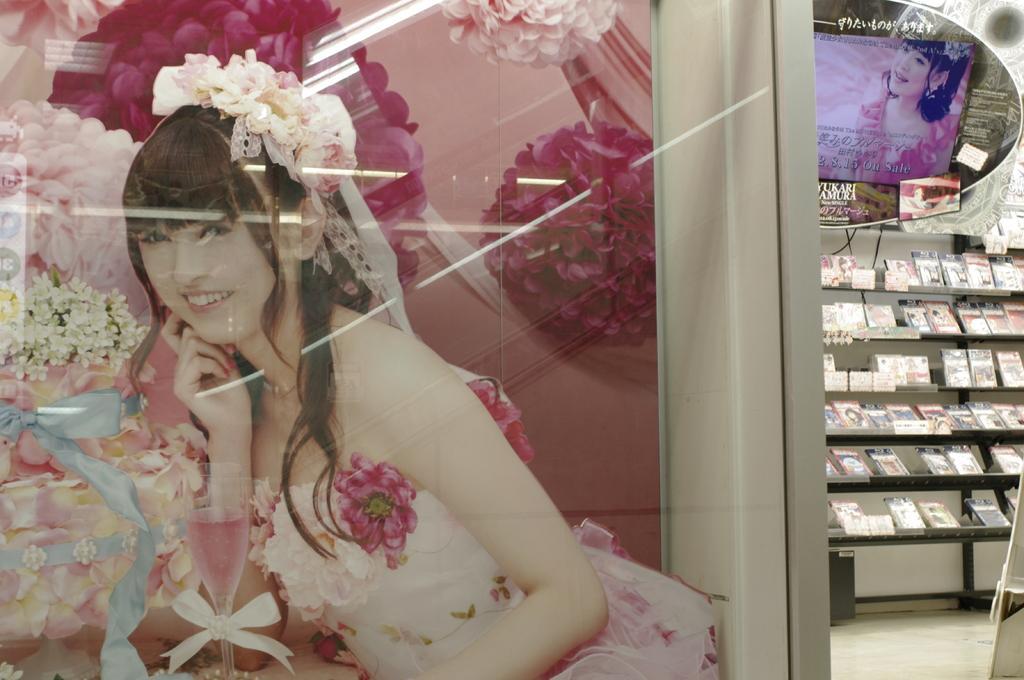Can you describe this image briefly? In this image in front there is a poster. In the background of the image there are objects in the shelf. At the bottom of the image there is a floor. 